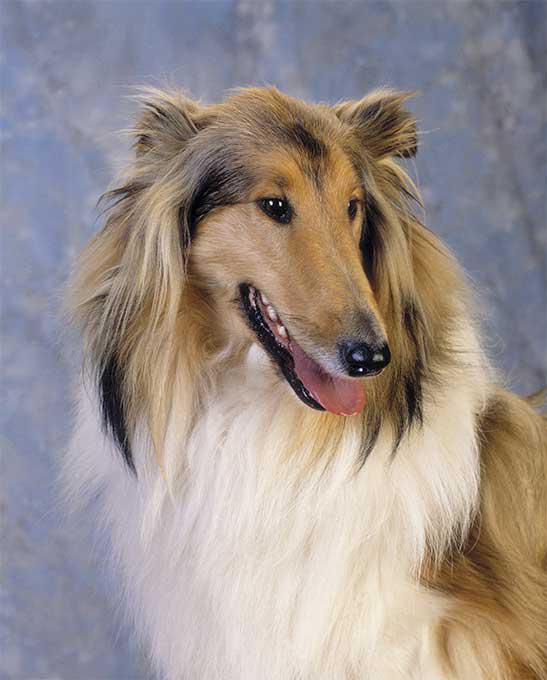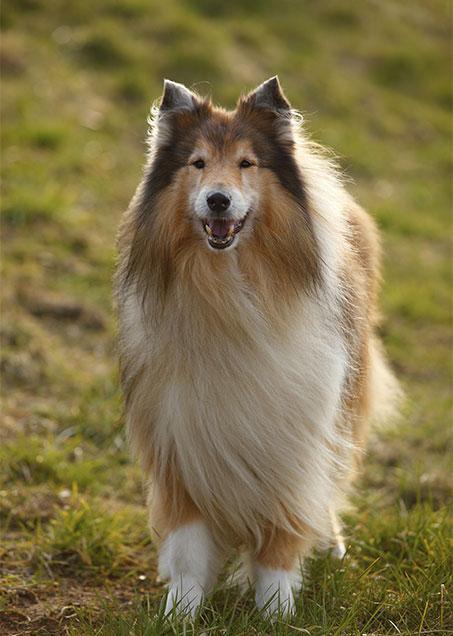The first image is the image on the left, the second image is the image on the right. For the images shown, is this caption "The dog in the image on the right is moving toward the camera" true? Answer yes or no. Yes. 